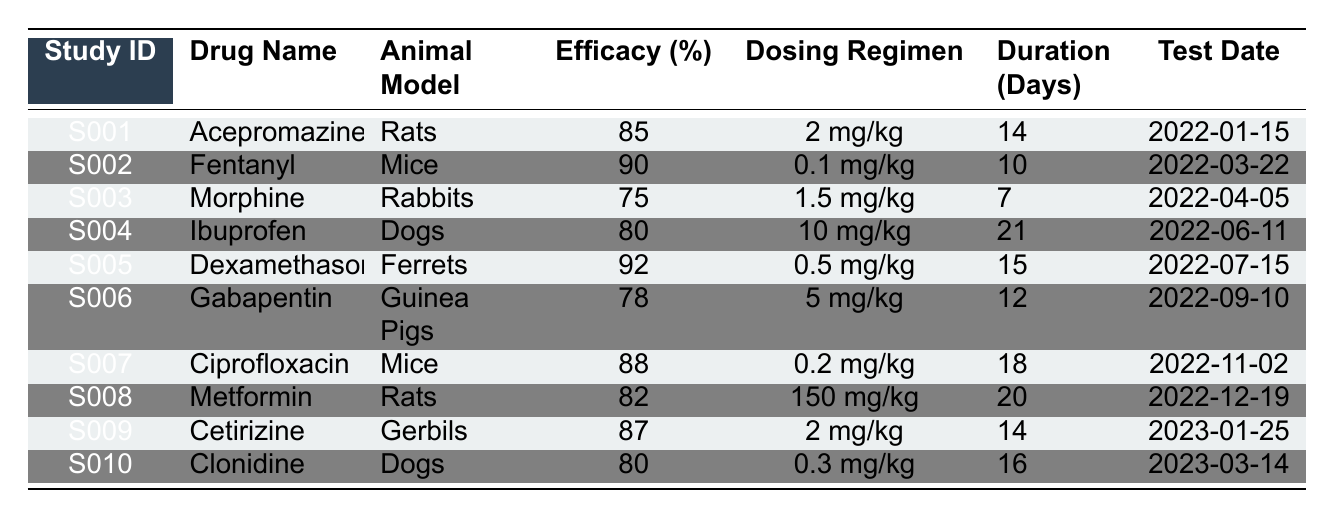What is the efficacy percentage of Dexamethasone in Ferrets? Referring to the table, the row for Dexamethasone shows an efficacy percentage of 92 when tested on ferrets.
Answer: 92 Which drug had the lowest efficacy percentage in the tests? By comparing the efficacy percentages in the table, Morphine shows the lowest value at 75%.
Answer: 75 What is the average efficacy percentage of drugs tested on Mice? The drugs tested on mice are Fentanyl (90%) and Ciprofloxacin (88%). The average is (90 + 88) / 2 = 89%.
Answer: 89 How many days was Ibuprofen administered to Dogs? The duration for Ibuprofen in the table is listed as 21 days for dogs.
Answer: 21 days Is Clonidine’s efficacy percentage greater than 80%? In the table, Clonidine has an efficacy percentage of 80%, which is not greater than 80%. Therefore, the statement is false.
Answer: No What is the total duration of drug testing for Rats? The drugs tested on Rats are Acepromazine (14 days) and Metformin (20 days). Adding these gives a total duration of 14 + 20 = 34 days.
Answer: 34 days Between Ferrets and Rabbits, which drug had higher efficacy? Dexamethasone in Ferrets has an efficacy of 92%, while Morphine in Rabbits has an efficacy of 75%. Therefore, Dexamethasone is higher.
Answer: Dexamethasone How many different animal models were used for drug testing in this study? The table includes Rats, Mice, Rabbits, Dogs, Ferrets, Guinea Pigs, and Gerbils, making a total of 7 unique animal models.
Answer: 7 What is the dosing regimen of the drug with the highest efficacy percentage? The drug with the highest efficacy is Dexamethasone at 92%. Its dosing regimen is 0.5 mg/kg.
Answer: 0.5 mg/kg Which drug was tested most recently according to the test date? The most recent test date in the table is for Clonidine on 2023-03-14.
Answer: Clonidine 